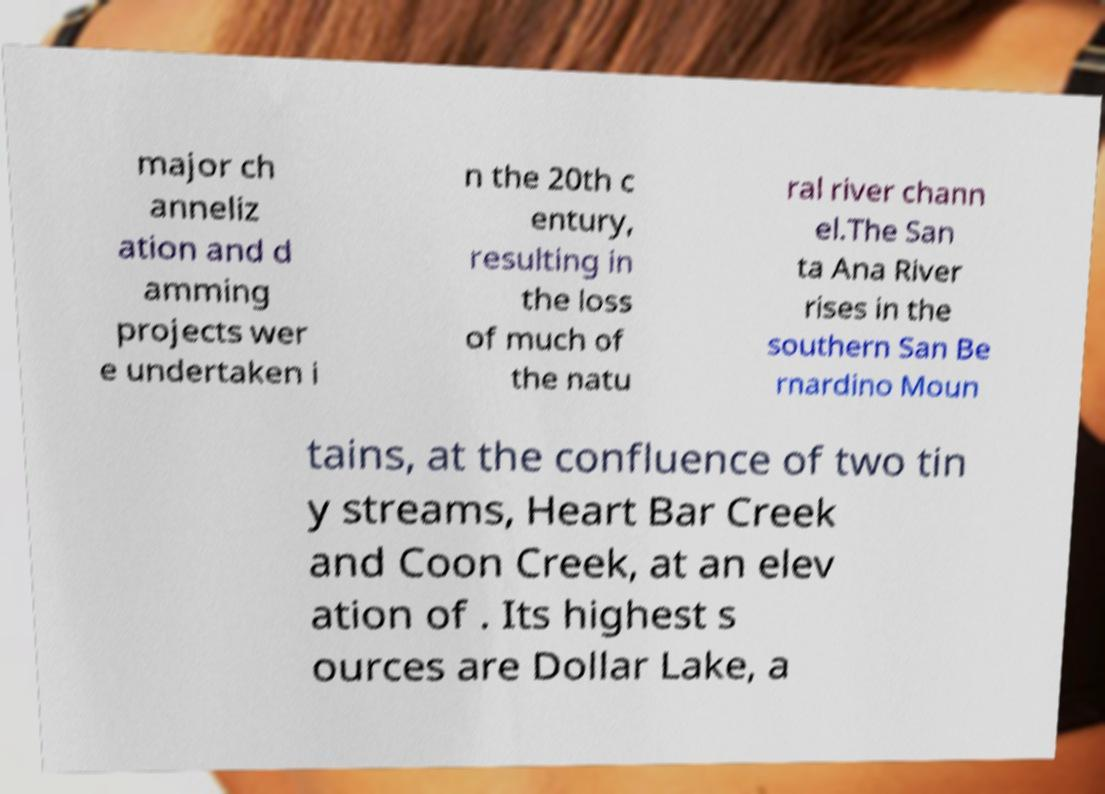There's text embedded in this image that I need extracted. Can you transcribe it verbatim? major ch anneliz ation and d amming projects wer e undertaken i n the 20th c entury, resulting in the loss of much of the natu ral river chann el.The San ta Ana River rises in the southern San Be rnardino Moun tains, at the confluence of two tin y streams, Heart Bar Creek and Coon Creek, at an elev ation of . Its highest s ources are Dollar Lake, a 